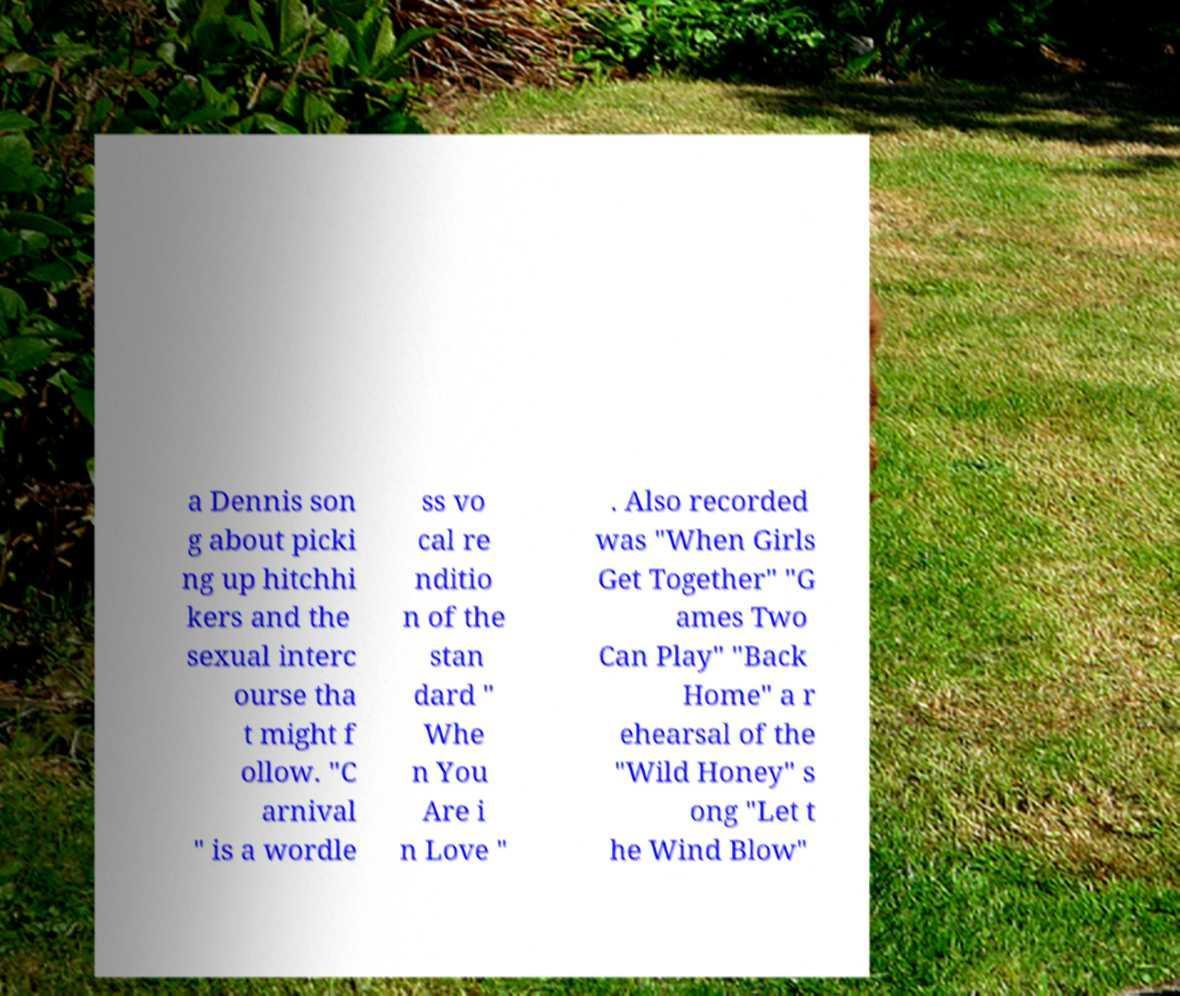What messages or text are displayed in this image? I need them in a readable, typed format. a Dennis son g about picki ng up hitchhi kers and the sexual interc ourse tha t might f ollow. "C arnival " is a wordle ss vo cal re nditio n of the stan dard " Whe n You Are i n Love " . Also recorded was "When Girls Get Together" "G ames Two Can Play" "Back Home" a r ehearsal of the "Wild Honey" s ong "Let t he Wind Blow" 